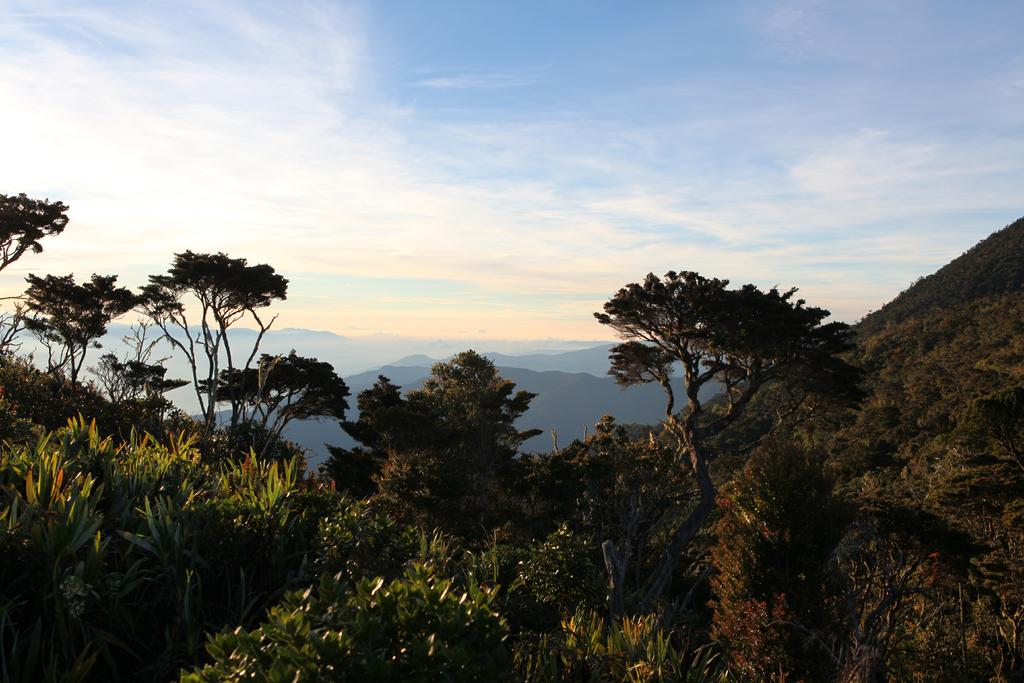Where was the image taken? The image was taken on a hill. What can be seen at the bottom of the hill? There are plants and trees at the bottom of the hill. What can be seen in the distance in the image? There are hills visible in the background. What else is visible in the background of the image? The sky is visible in the background. What type of butter is being used to grease the celery in the image? There is no butter or celery present in the image; it features a hill with plants and trees at the bottom and hills and sky in the background. 